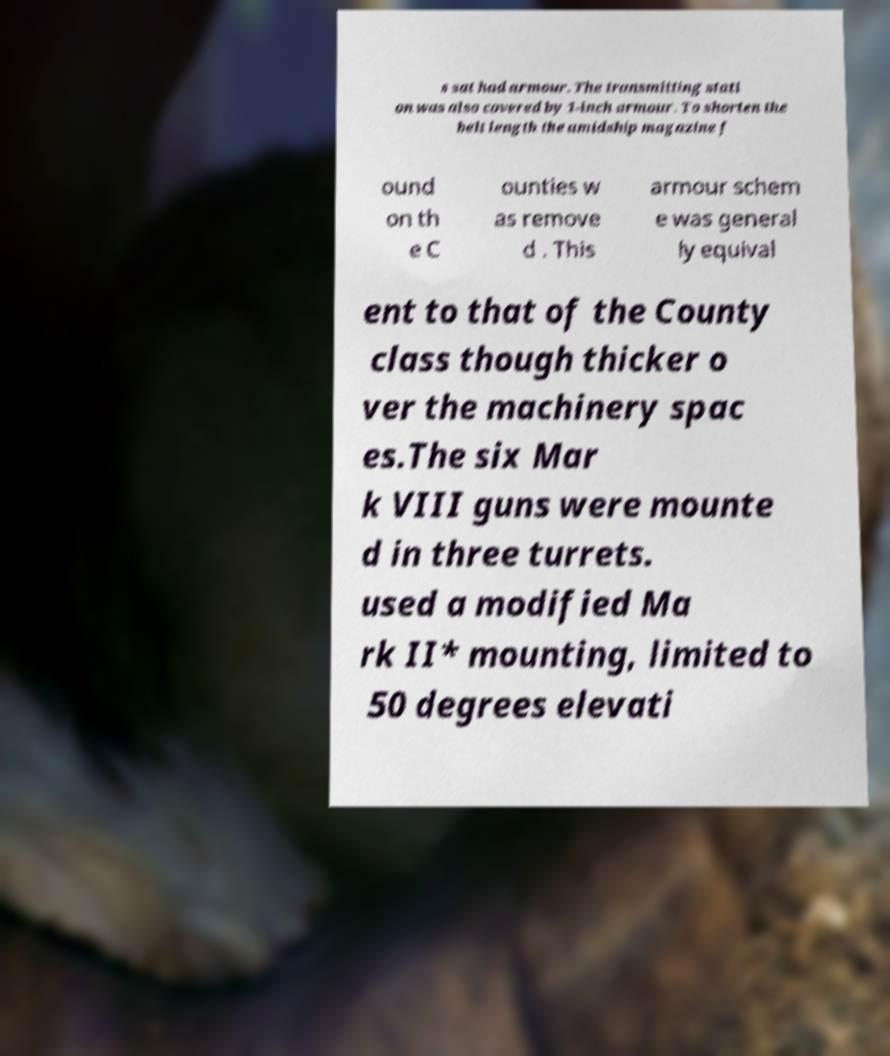Please identify and transcribe the text found in this image. s sat had armour. The transmitting stati on was also covered by 1-inch armour. To shorten the belt length the amidship magazine f ound on th e C ounties w as remove d . This armour schem e was general ly equival ent to that of the County class though thicker o ver the machinery spac es.The six Mar k VIII guns were mounte d in three turrets. used a modified Ma rk II* mounting, limited to 50 degrees elevati 